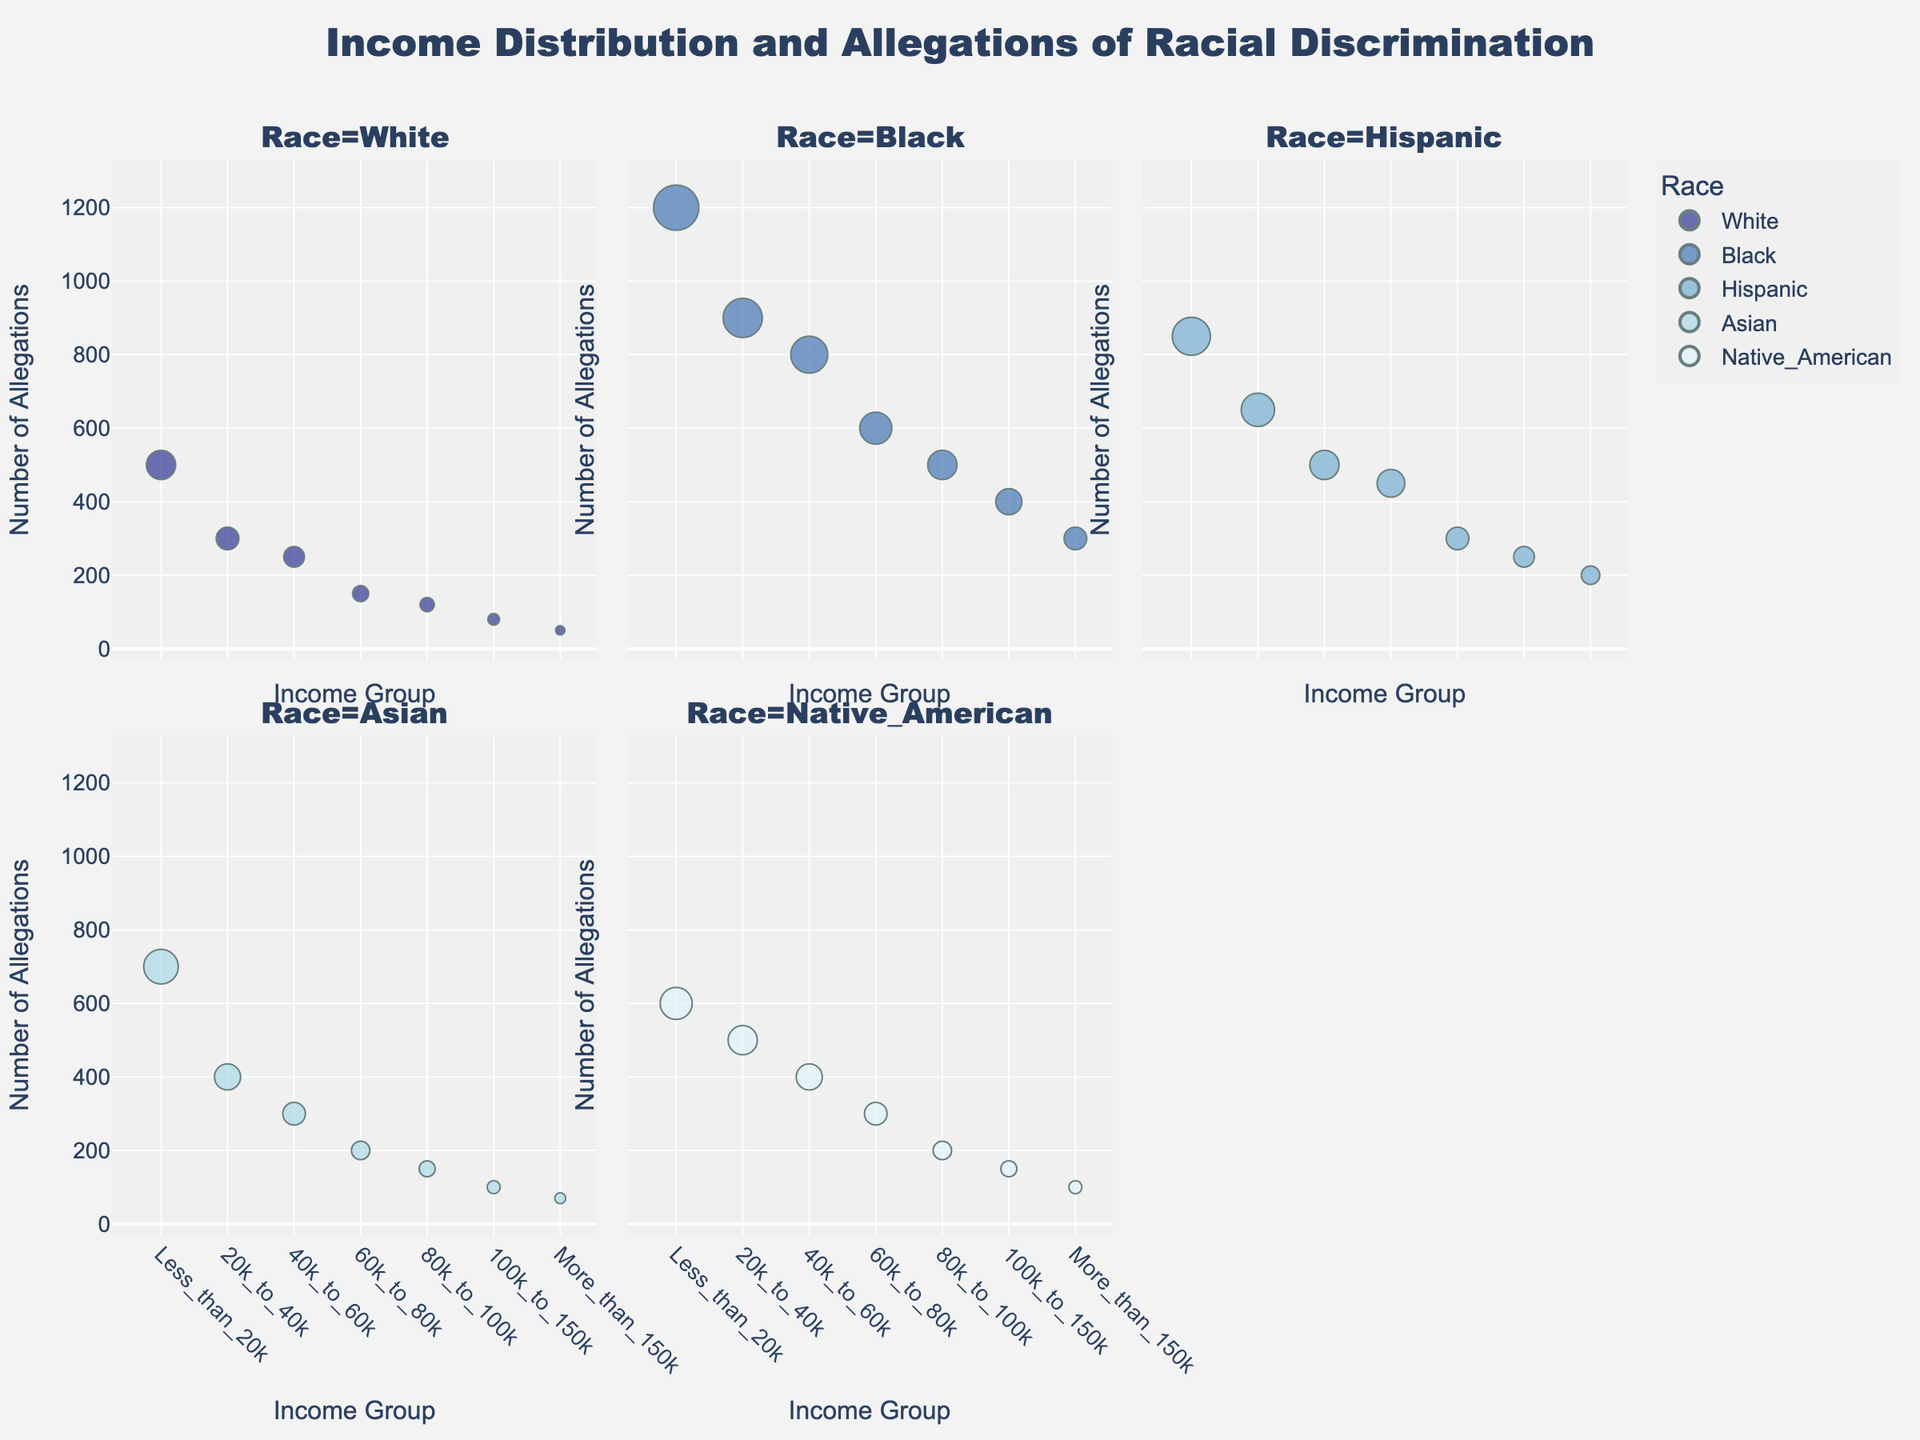What is the title of the figure? The title is usually placed at the top of the figure and contains text summarizing the data displayed.
Answer: Income Distribution and Allegations of Racial Discrimination Which income group has the highest number of allegations of racial discrimination among Blacks? By looking at the facet plot for Blacks, identify the income group with the tallest point.
Answer: Less_than_20k Which racial group has the lowest number of allegations in the income group 40k_to_60k? Compare the heights of the points in the 40k_to_60k vertical strip across all racial groups.
Answer: Asian How does the number of allegations in the 20k_to_40k income group for Hispanics compare to those for Asians? Look at the points for the 20k_to_40k income group in the Hispanic and Asian facets and compare their heights.
Answer: Higher Which income group for Native Americans shows more allegations, 60k_to_80k or 100k_to_150k? Compare the heights of the points for 60k_to_80k and 100k_to_150k within the Native American facet.
Answer: 60k_to_80k What is the trend of allegations with increasing income for Whites? Observe the change in heights of points from the leftmost to the rightmost edge for the White facet.
Answer: Decreasing Which racial group has the most consistent number of allegations across all income groups? Identify the racial group where the heights of points (indicating allegations) are least variable across income groups.
Answer: Native American Is there an income group where all racial groups have fewer than 200 allegations of discrimination? Check each income group to see if all racial groups in that group have points below the 200-mark horizontal line.
Answer: No Which two racial groups have the most similar number of allegations in the income group 80k_to_100k? Compare the heights of points in the income group 80k_to_100k in the facets of different racial groups and find the two closest.
Answer: Asian and Native American Summarize the correlation between income level and allegations of racial discrimination among Black individuals. Observe the general trend in the facet for Blacks, noting the change in height of points across different income groups.
Answer: Higher income groups generally have fewer allegations 